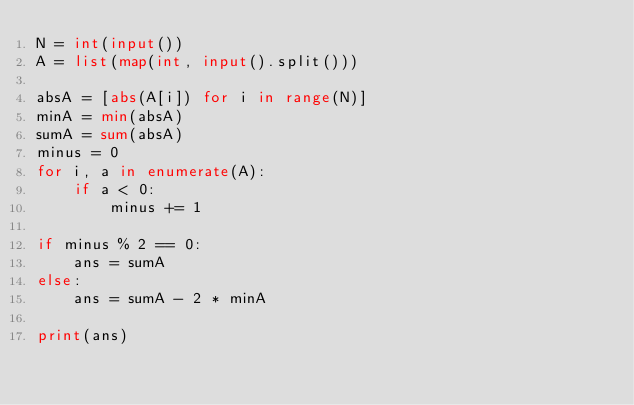<code> <loc_0><loc_0><loc_500><loc_500><_Python_>N = int(input())
A = list(map(int, input().split()))

absA = [abs(A[i]) for i in range(N)]
minA = min(absA)
sumA = sum(absA)
minus = 0
for i, a in enumerate(A):
    if a < 0:
        minus += 1

if minus % 2 == 0:
    ans = sumA
else:
    ans = sumA - 2 * minA

print(ans)</code> 